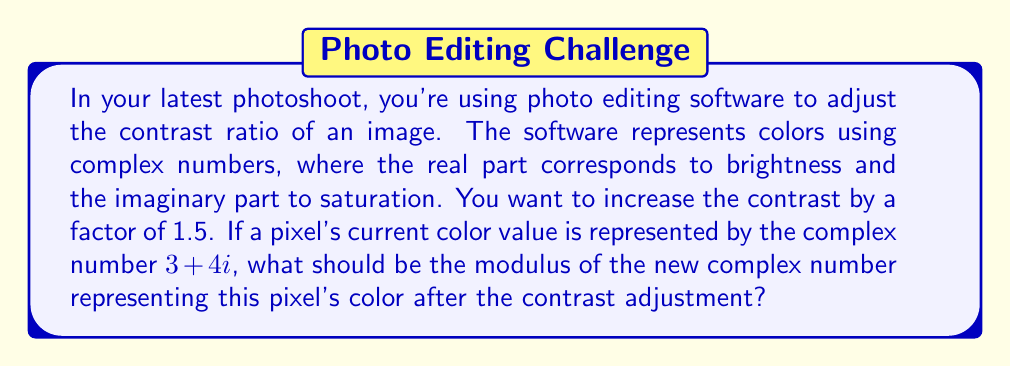Show me your answer to this math problem. Let's approach this step-by-step:

1) First, recall that the modulus of a complex number $a + bi$ is given by:

   $$|a + bi| = \sqrt{a^2 + b^2}$$

2) For the given complex number $3 + 4i$, we can calculate its current modulus:

   $$|3 + 4i| = \sqrt{3^2 + 4^2} = \sqrt{9 + 16} = \sqrt{25} = 5$$

3) To increase the contrast by a factor of 1.5, we need to multiply the modulus by 1.5:

   $$\text{New modulus} = 1.5 \times \text{Current modulus}$$
   $$\text{New modulus} = 1.5 \times 5 = 7.5$$

4) Therefore, after the contrast adjustment, the new complex number representing this pixel's color should have a modulus of 7.5.
Answer: $7.5$ 